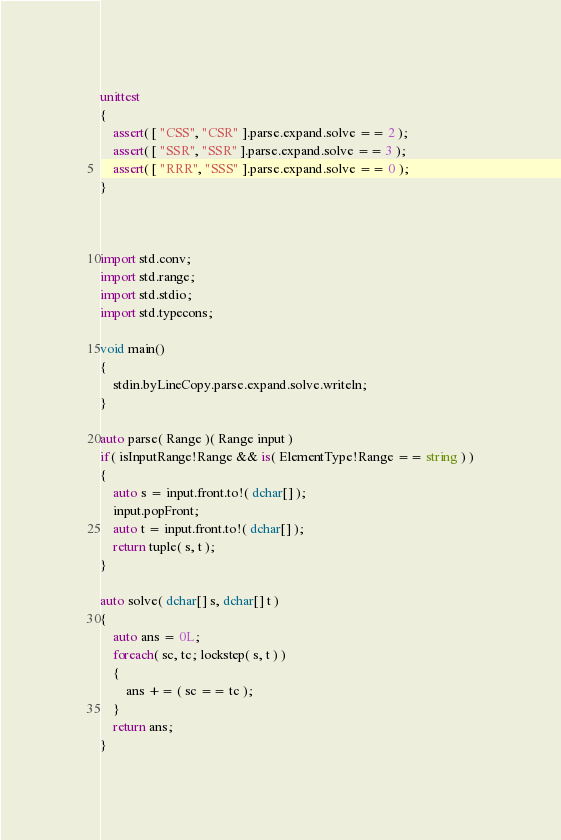Convert code to text. <code><loc_0><loc_0><loc_500><loc_500><_D_>unittest
{
	assert( [ "CSS", "CSR" ].parse.expand.solve == 2 );
	assert( [ "SSR", "SSR" ].parse.expand.solve == 3 );
	assert( [ "RRR", "SSS" ].parse.expand.solve == 0 );
}



import std.conv;
import std.range;
import std.stdio;
import std.typecons;

void main()
{
	stdin.byLineCopy.parse.expand.solve.writeln;
}

auto parse( Range )( Range input )
if( isInputRange!Range && is( ElementType!Range == string ) )
{
	auto s = input.front.to!( dchar[] );
	input.popFront;
	auto t = input.front.to!( dchar[] );
	return tuple( s, t );
}

auto solve( dchar[] s, dchar[] t )
{
	auto ans = 0L;
	foreach( sc, tc; lockstep( s, t ) )
	{
		ans += ( sc == tc );
	}
	return ans;
}
</code> 